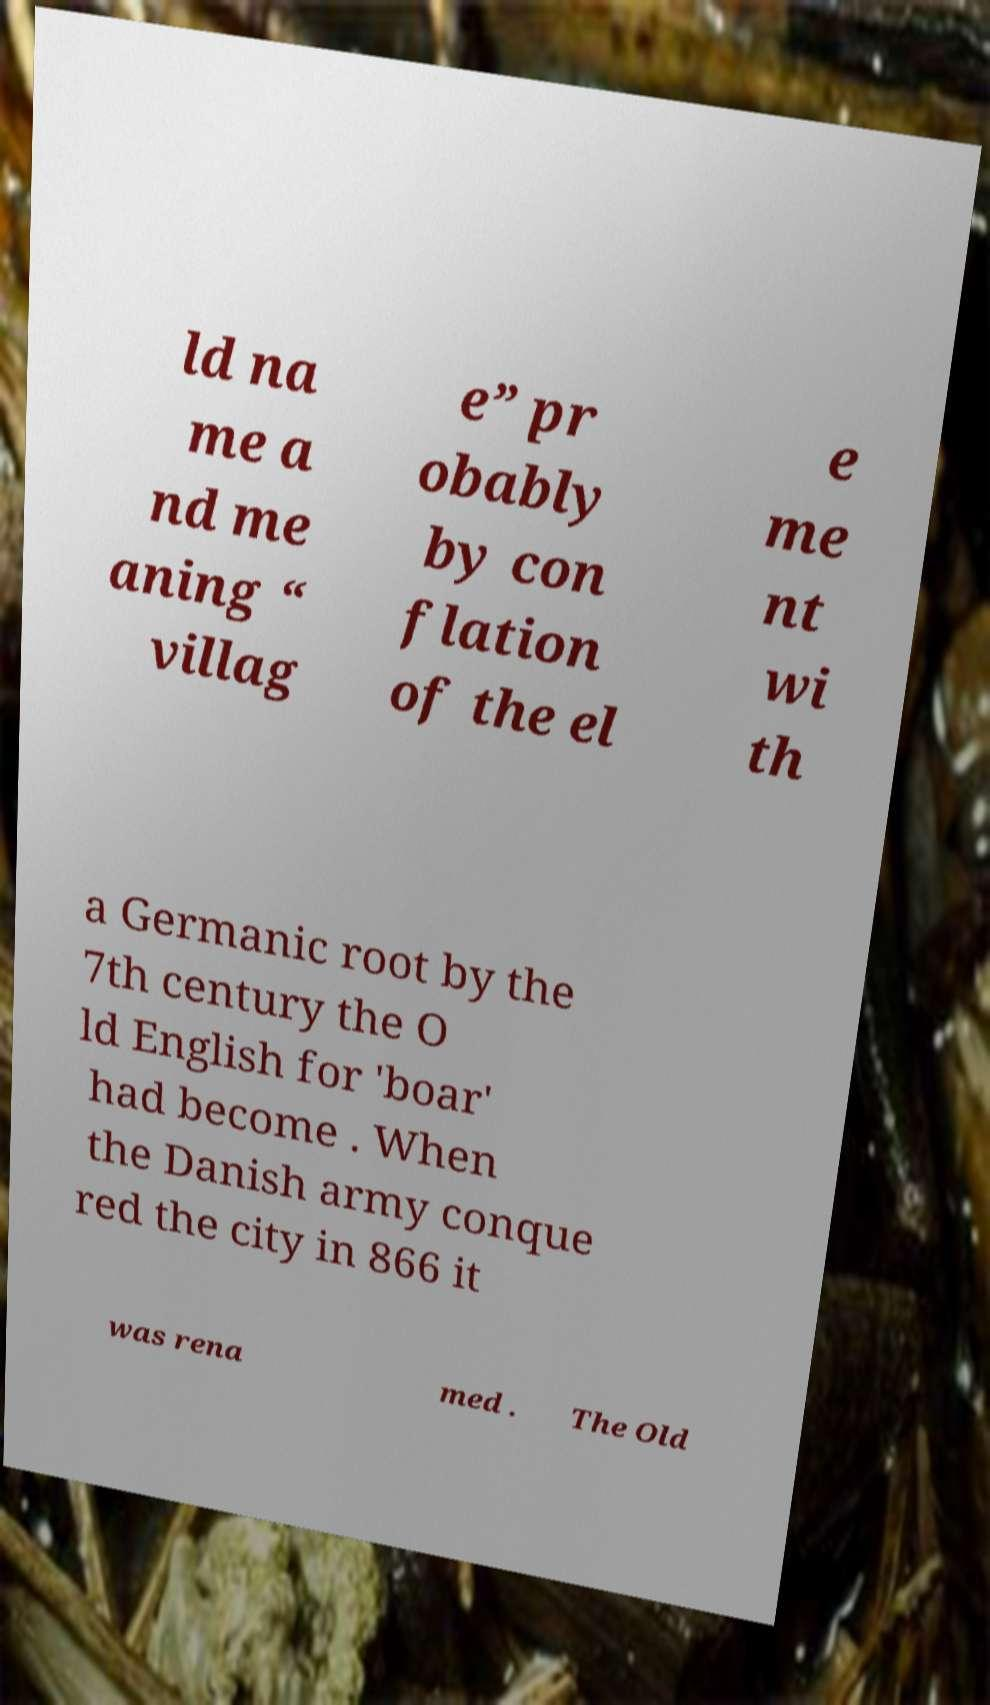I need the written content from this picture converted into text. Can you do that? ld na me a nd me aning “ villag e” pr obably by con flation of the el e me nt wi th a Germanic root by the 7th century the O ld English for 'boar' had become . When the Danish army conque red the city in 866 it was rena med . The Old 